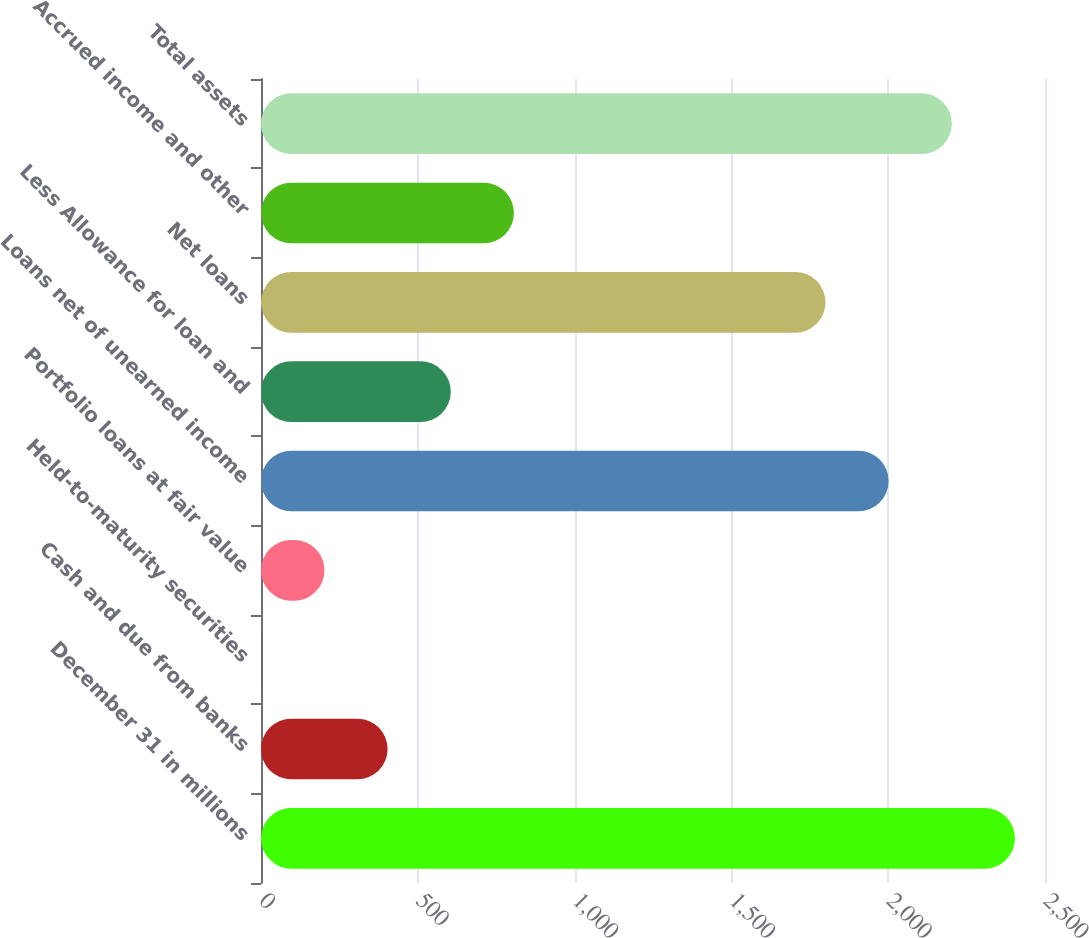Convert chart. <chart><loc_0><loc_0><loc_500><loc_500><bar_chart><fcel>December 31 in millions<fcel>Cash and due from banks<fcel>Held-to-maturity securities<fcel>Portfolio loans at fair value<fcel>Loans net of unearned income<fcel>Less Allowance for loan and<fcel>Net loans<fcel>Accrued income and other<fcel>Total assets<nl><fcel>2404.2<fcel>403.8<fcel>1<fcel>202.4<fcel>2001.4<fcel>605.2<fcel>1800<fcel>806.6<fcel>2202.8<nl></chart> 